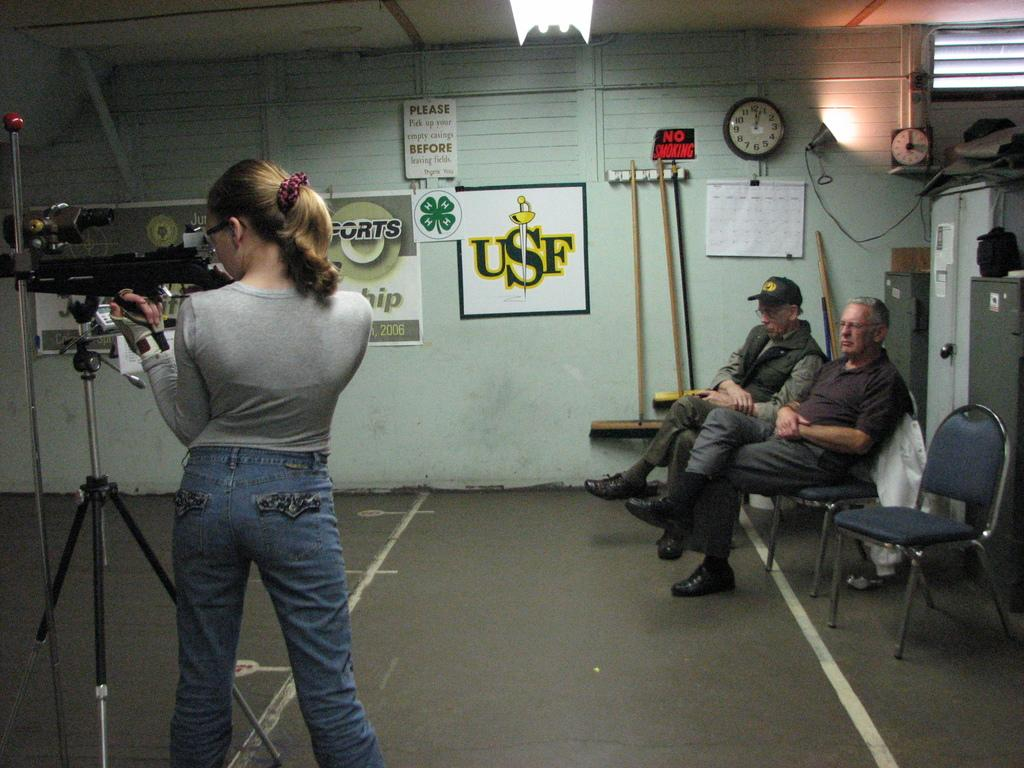What is the primary subject of the image? There is a woman in the image. What is the woman doing in the image? The woman is standing and holding a gun in her hand. What are the two men in the image doing? The men are seated on chairs and watching the woman. What objects can be seen on the wall in the image? There is a wall clock and a poster on the wall. What type of mint is growing on the floor in the image? There is no mint growing on the floor in the image. What payment method is being used for the transaction in the image? There is no transaction or payment method depicted in the image. 